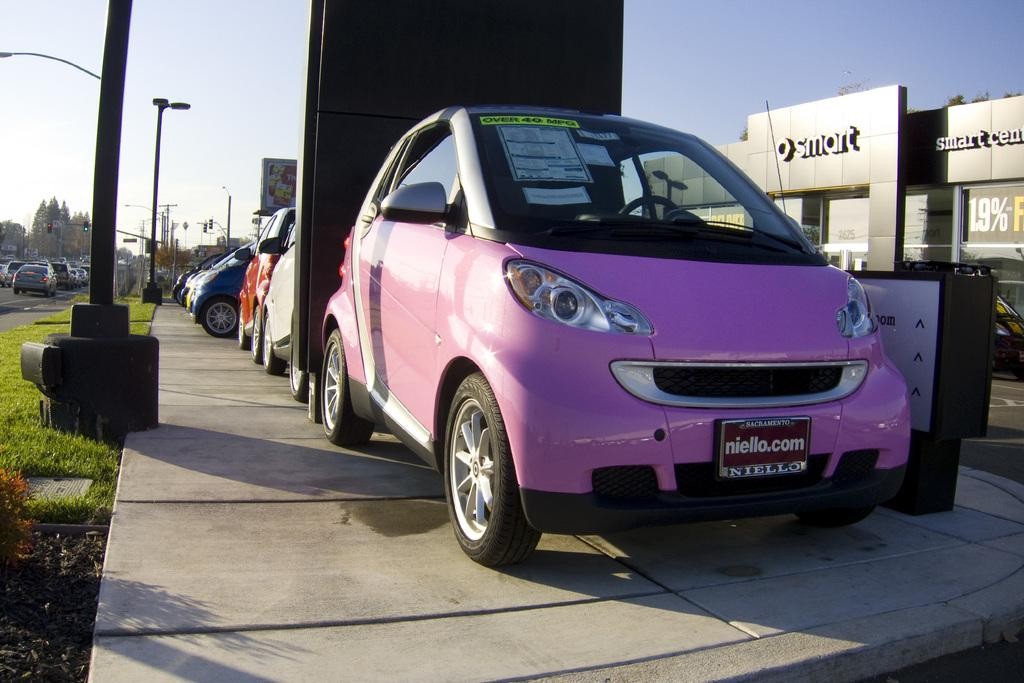What type of vehicles can be seen in the image? There are cars in the image. What other objects can be seen in the image besides cars? There are poles, trees, boards, and grass visible in the image. What is visible in the background of the image? The sky is visible in the background of the image. What type of lead can be seen in the image? There is no lead present in the image. What type of floor can be seen in the image? There is no floor present in the image; it is an outdoor scene with grass and other objects. 